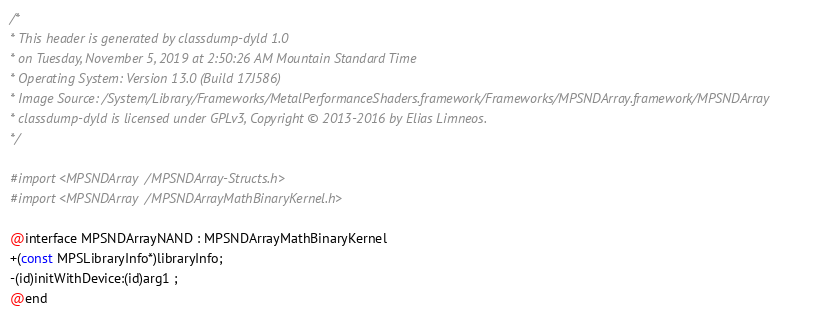<code> <loc_0><loc_0><loc_500><loc_500><_C_>/*
* This header is generated by classdump-dyld 1.0
* on Tuesday, November 5, 2019 at 2:50:26 AM Mountain Standard Time
* Operating System: Version 13.0 (Build 17J586)
* Image Source: /System/Library/Frameworks/MetalPerformanceShaders.framework/Frameworks/MPSNDArray.framework/MPSNDArray
* classdump-dyld is licensed under GPLv3, Copyright © 2013-2016 by Elias Limneos.
*/

#import <MPSNDArray/MPSNDArray-Structs.h>
#import <MPSNDArray/MPSNDArrayMathBinaryKernel.h>

@interface MPSNDArrayNAND : MPSNDArrayMathBinaryKernel
+(const MPSLibraryInfo*)libraryInfo;
-(id)initWithDevice:(id)arg1 ;
@end

</code> 